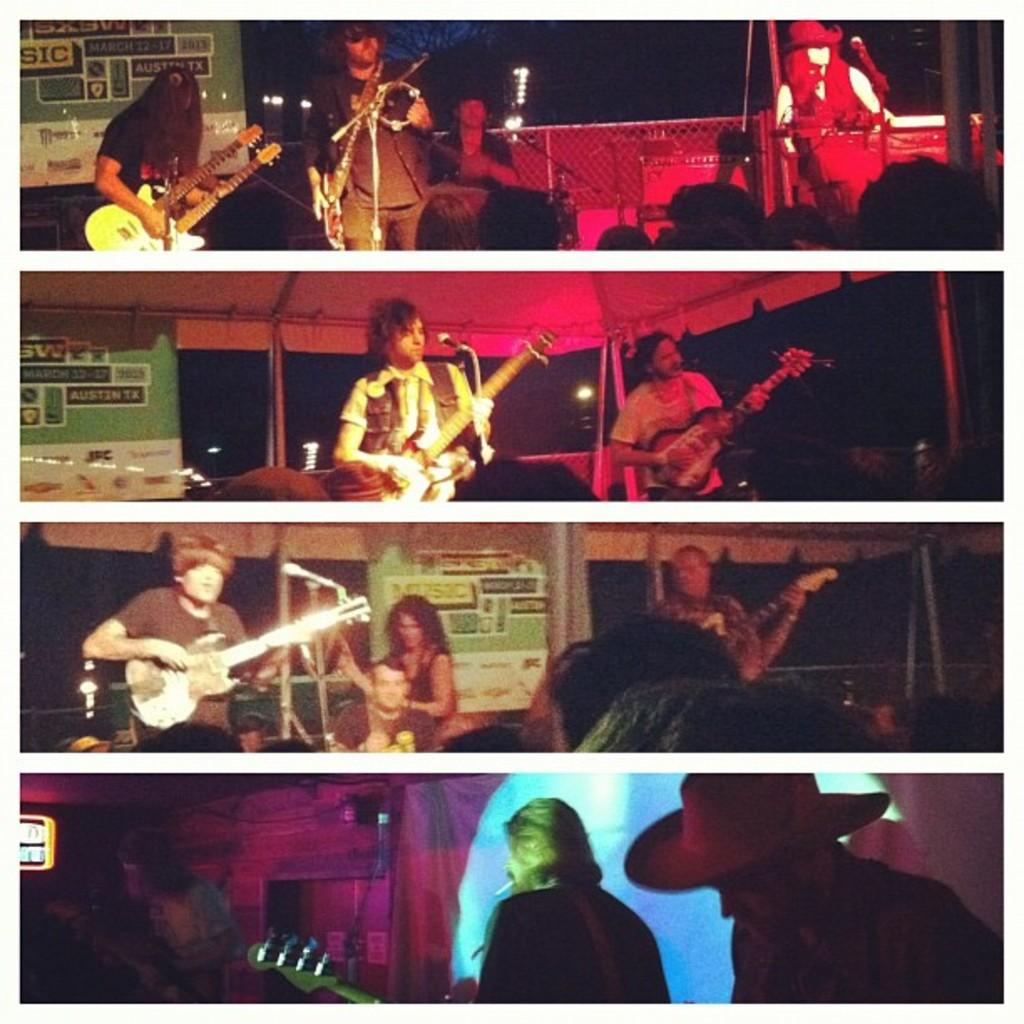What type of artwork is the image? The image is a collage. What can be seen in the collage? There are people in the image. What are the people doing in the collage? The people are playing musical instruments. What type of rake is being used by the person in the image? There is no rake present in the image; the people are playing musical instruments. How are the scissors being used in the image? There are no scissors present in the image; the people are playing musical instruments. 